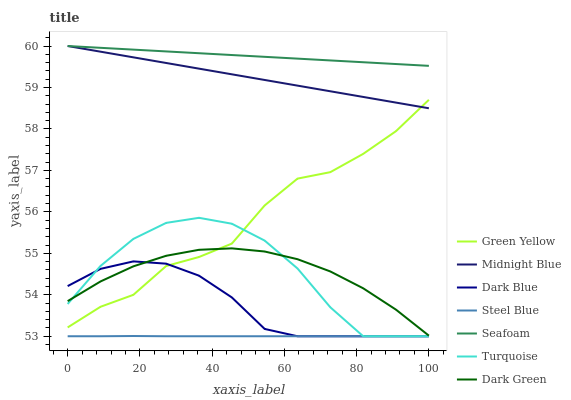Does Midnight Blue have the minimum area under the curve?
Answer yes or no. No. Does Midnight Blue have the maximum area under the curve?
Answer yes or no. No. Is Midnight Blue the smoothest?
Answer yes or no. No. Is Midnight Blue the roughest?
Answer yes or no. No. Does Midnight Blue have the lowest value?
Answer yes or no. No. Does Steel Blue have the highest value?
Answer yes or no. No. Is Steel Blue less than Dark Green?
Answer yes or no. Yes. Is Green Yellow greater than Steel Blue?
Answer yes or no. Yes. Does Steel Blue intersect Dark Green?
Answer yes or no. No. 